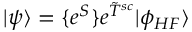Convert formula to latex. <formula><loc_0><loc_0><loc_500><loc_500>| \psi \rangle = \{ e ^ { S } \} e ^ { \tilde { T } ^ { s c } } | \phi _ { H F } \rangle</formula> 